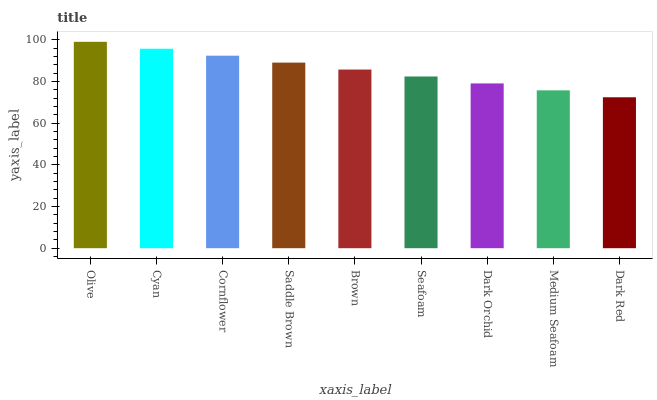Is Dark Red the minimum?
Answer yes or no. Yes. Is Olive the maximum?
Answer yes or no. Yes. Is Cyan the minimum?
Answer yes or no. No. Is Cyan the maximum?
Answer yes or no. No. Is Olive greater than Cyan?
Answer yes or no. Yes. Is Cyan less than Olive?
Answer yes or no. Yes. Is Cyan greater than Olive?
Answer yes or no. No. Is Olive less than Cyan?
Answer yes or no. No. Is Brown the high median?
Answer yes or no. Yes. Is Brown the low median?
Answer yes or no. Yes. Is Dark Orchid the high median?
Answer yes or no. No. Is Medium Seafoam the low median?
Answer yes or no. No. 